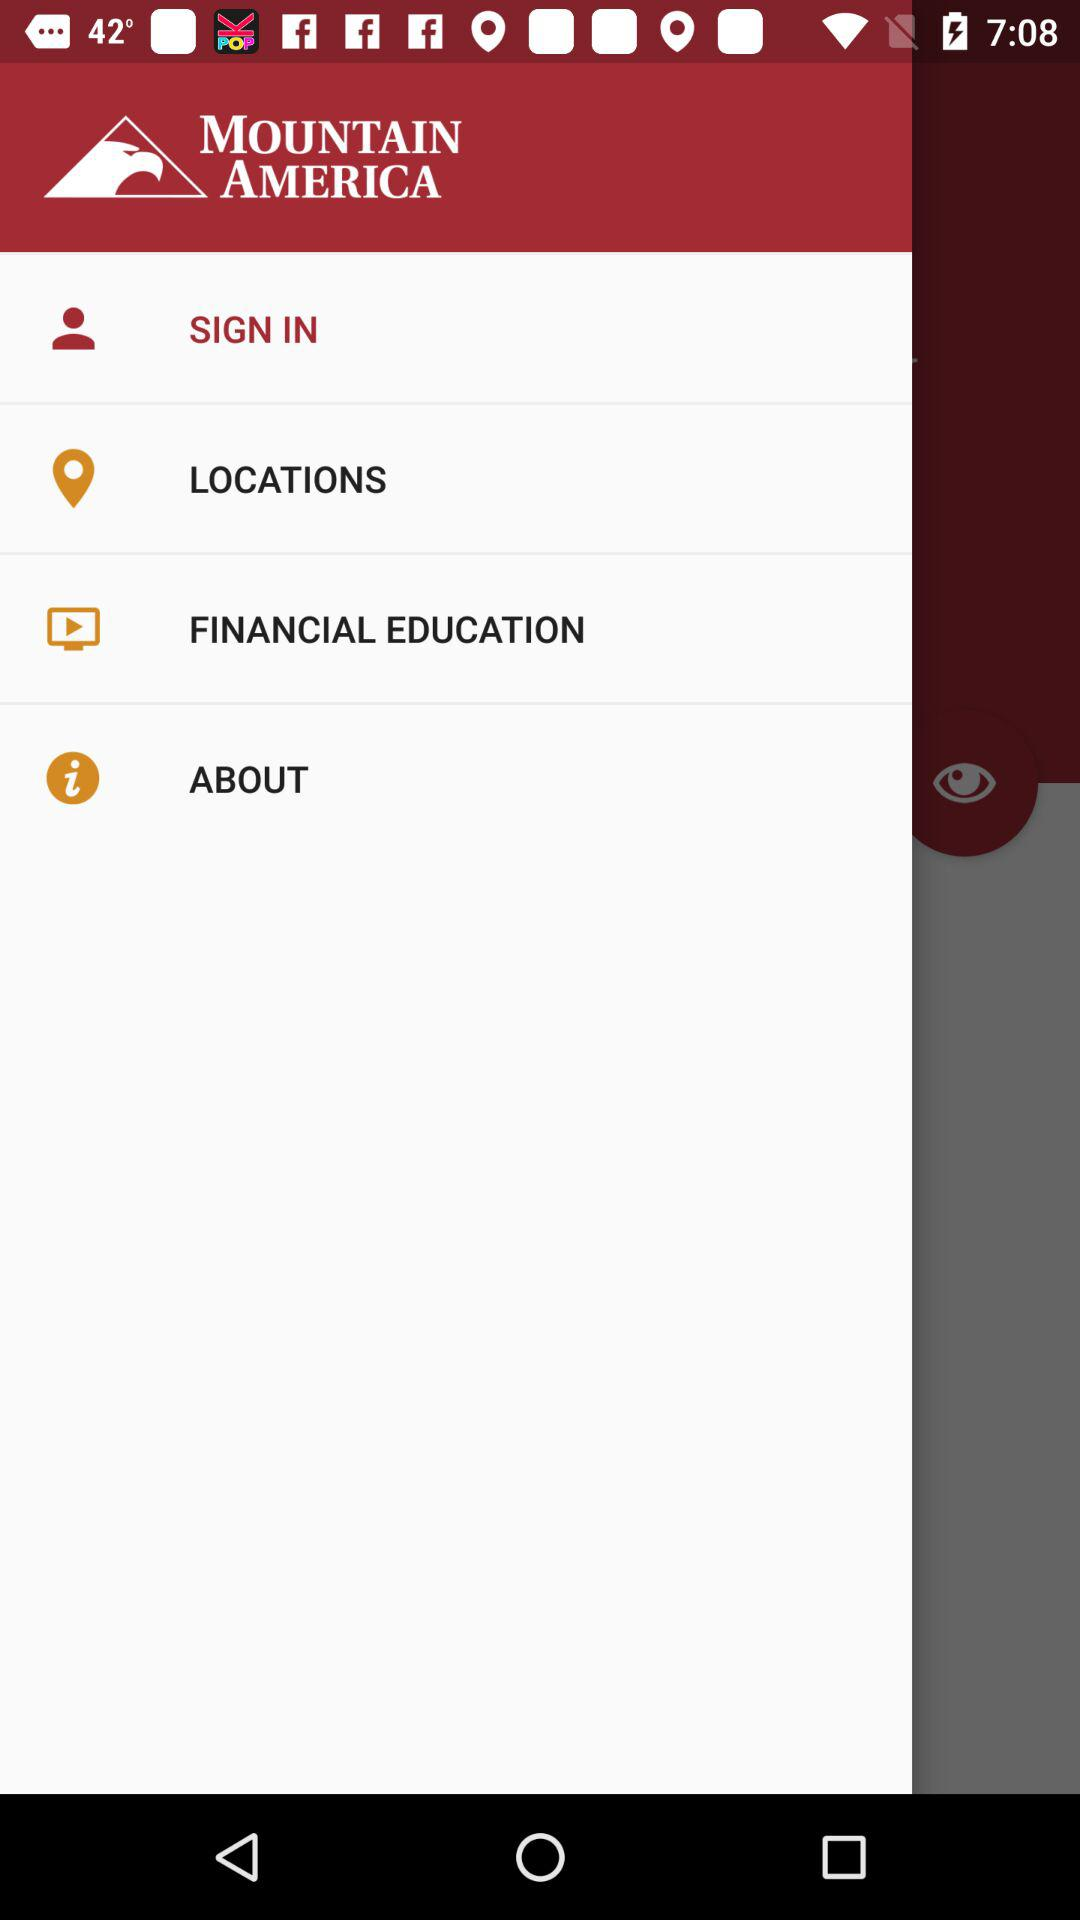What is the application name? The application name is "MOUNTAIN AMERICA". 